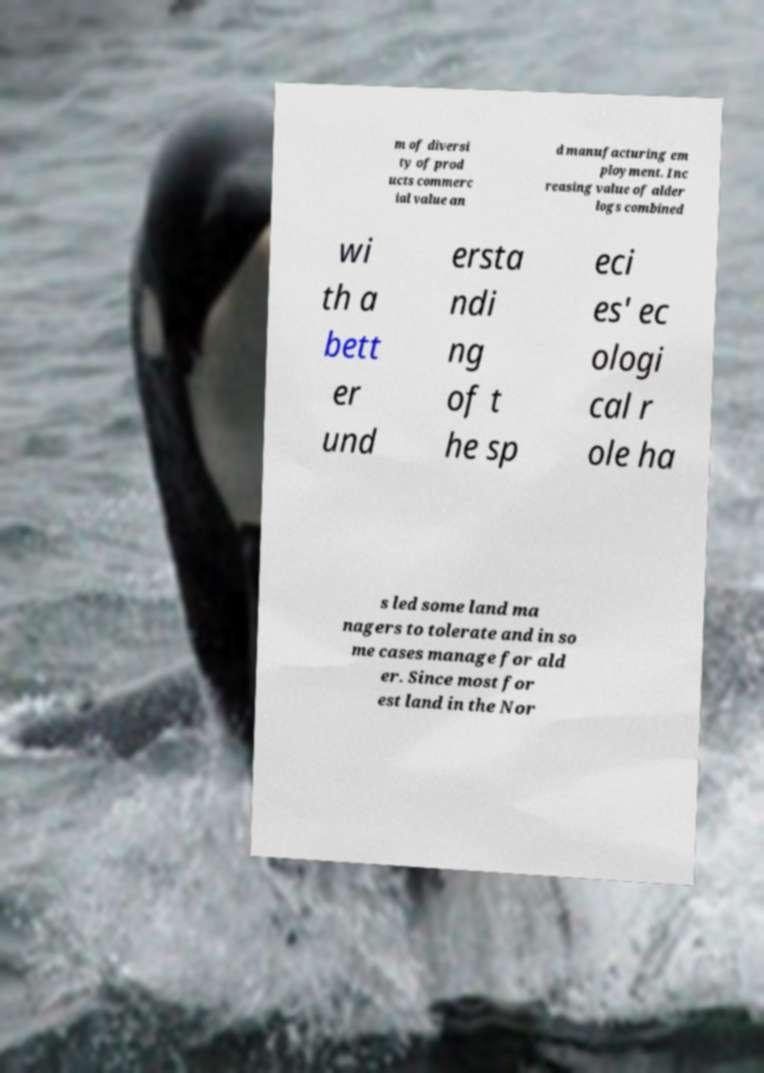Please identify and transcribe the text found in this image. m of diversi ty of prod ucts commerc ial value an d manufacturing em ployment. Inc reasing value of alder logs combined wi th a bett er und ersta ndi ng of t he sp eci es' ec ologi cal r ole ha s led some land ma nagers to tolerate and in so me cases manage for ald er. Since most for est land in the Nor 